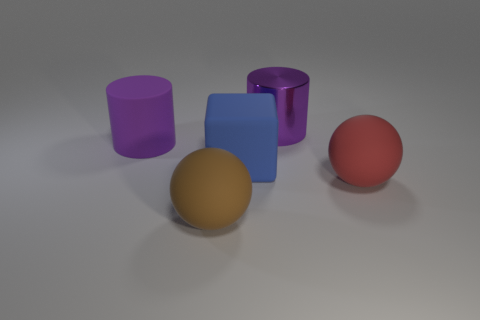How many matte objects are to the left of the red object and on the right side of the rubber cylinder?
Your answer should be compact. 2. There is a object on the left side of the brown matte ball; how many large objects are in front of it?
Offer a very short reply. 3. What number of things are rubber balls that are behind the large brown matte ball or blue things behind the large red ball?
Offer a very short reply. 2. There is another big thing that is the same shape as the large purple rubber thing; what material is it?
Provide a short and direct response. Metal. How many objects are big things behind the large brown thing or large purple metal things?
Offer a terse response. 4. The red thing that is the same material as the large blue block is what shape?
Make the answer very short. Sphere. What number of other objects are the same shape as the big purple rubber object?
Provide a short and direct response. 1. What is the big red thing made of?
Your response must be concise. Rubber. There is a large matte cylinder; does it have the same color as the ball that is on the right side of the large blue matte object?
Provide a succinct answer. No. What number of cylinders are either big red objects or blue rubber objects?
Offer a terse response. 0. 